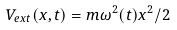<formula> <loc_0><loc_0><loc_500><loc_500>V _ { e x t } ( x , t ) = m \omega ^ { 2 } ( t ) x ^ { 2 } / 2</formula> 